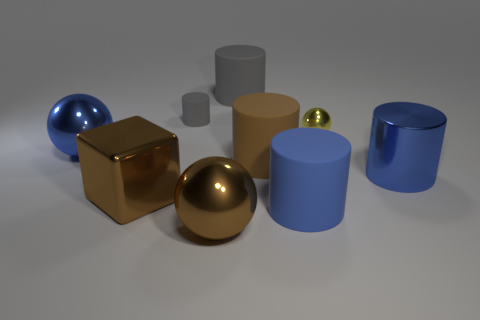Is there another cylinder that has the same color as the small cylinder?
Your answer should be compact. Yes. How many big brown objects are both in front of the metallic cylinder and behind the big shiny cylinder?
Offer a very short reply. 0. The rubber thing that is the same color as the large block is what shape?
Your response must be concise. Cylinder. What is the material of the big object that is left of the big gray object and to the right of the large cube?
Offer a terse response. Metal. Is the number of gray cylinders that are on the right side of the large brown rubber cylinder less than the number of blue metallic spheres that are behind the yellow metallic object?
Your response must be concise. No. What size is the cube that is the same material as the yellow object?
Provide a short and direct response. Large. Is there any other thing of the same color as the tiny metal ball?
Provide a short and direct response. No. Is the large blue ball made of the same material as the gray cylinder behind the tiny rubber cylinder?
Your response must be concise. No. What is the material of the tiny gray object that is the same shape as the large brown matte thing?
Offer a very short reply. Rubber. Is there anything else that has the same material as the brown cube?
Offer a terse response. Yes. 